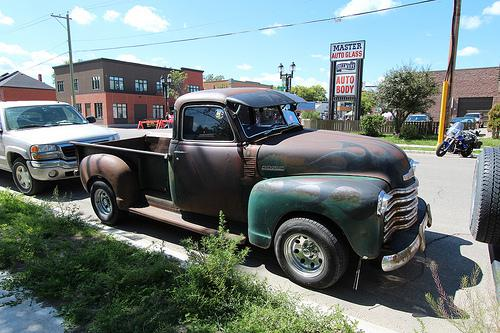Question: what kind of vehicle is across the street?
Choices:
A. A motorcycle.
B. A car.
C. A bicycle.
D. A tricycle.
Answer with the letter. Answer: A 